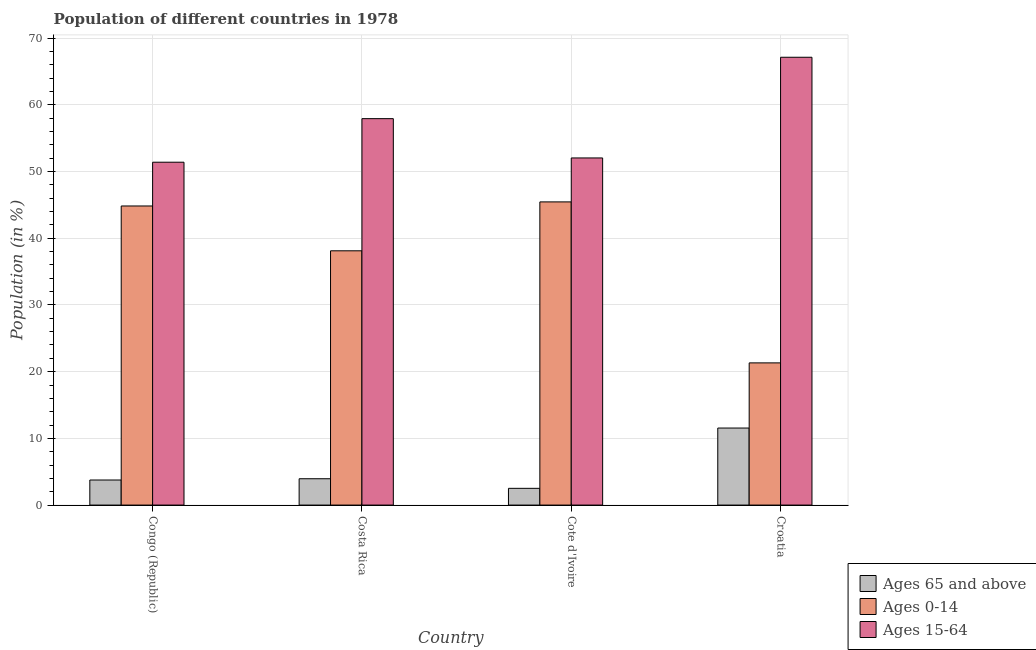Are the number of bars per tick equal to the number of legend labels?
Your response must be concise. Yes. How many bars are there on the 1st tick from the right?
Ensure brevity in your answer.  3. What is the label of the 4th group of bars from the left?
Give a very brief answer. Croatia. In how many cases, is the number of bars for a given country not equal to the number of legend labels?
Your response must be concise. 0. What is the percentage of population within the age-group of 65 and above in Croatia?
Provide a short and direct response. 11.55. Across all countries, what is the maximum percentage of population within the age-group 0-14?
Offer a very short reply. 45.45. Across all countries, what is the minimum percentage of population within the age-group 15-64?
Your response must be concise. 51.4. In which country was the percentage of population within the age-group 0-14 maximum?
Your answer should be compact. Cote d'Ivoire. In which country was the percentage of population within the age-group 15-64 minimum?
Provide a short and direct response. Congo (Republic). What is the total percentage of population within the age-group 0-14 in the graph?
Make the answer very short. 149.73. What is the difference between the percentage of population within the age-group of 65 and above in Costa Rica and that in Croatia?
Provide a short and direct response. -7.6. What is the difference between the percentage of population within the age-group of 65 and above in Croatia and the percentage of population within the age-group 15-64 in Cote d'Ivoire?
Offer a terse response. -40.49. What is the average percentage of population within the age-group of 65 and above per country?
Keep it short and to the point. 5.44. What is the difference between the percentage of population within the age-group of 65 and above and percentage of population within the age-group 0-14 in Costa Rica?
Offer a terse response. -34.17. In how many countries, is the percentage of population within the age-group of 65 and above greater than 22 %?
Your answer should be compact. 0. What is the ratio of the percentage of population within the age-group 0-14 in Congo (Republic) to that in Cote d'Ivoire?
Give a very brief answer. 0.99. Is the percentage of population within the age-group 15-64 in Cote d'Ivoire less than that in Croatia?
Make the answer very short. Yes. What is the difference between the highest and the second highest percentage of population within the age-group 0-14?
Provide a succinct answer. 0.61. What is the difference between the highest and the lowest percentage of population within the age-group 0-14?
Your response must be concise. 24.13. What does the 1st bar from the left in Congo (Republic) represents?
Give a very brief answer. Ages 65 and above. What does the 3rd bar from the right in Cote d'Ivoire represents?
Give a very brief answer. Ages 65 and above. Is it the case that in every country, the sum of the percentage of population within the age-group of 65 and above and percentage of population within the age-group 0-14 is greater than the percentage of population within the age-group 15-64?
Provide a short and direct response. No. Are all the bars in the graph horizontal?
Offer a very short reply. No. How many countries are there in the graph?
Offer a very short reply. 4. Does the graph contain any zero values?
Keep it short and to the point. No. Where does the legend appear in the graph?
Your answer should be compact. Bottom right. How many legend labels are there?
Make the answer very short. 3. What is the title of the graph?
Your response must be concise. Population of different countries in 1978. What is the label or title of the X-axis?
Give a very brief answer. Country. What is the Population (in %) in Ages 65 and above in Congo (Republic)?
Offer a terse response. 3.76. What is the Population (in %) of Ages 0-14 in Congo (Republic)?
Your response must be concise. 44.84. What is the Population (in %) in Ages 15-64 in Congo (Republic)?
Your response must be concise. 51.4. What is the Population (in %) of Ages 65 and above in Costa Rica?
Your answer should be very brief. 3.95. What is the Population (in %) in Ages 0-14 in Costa Rica?
Your response must be concise. 38.12. What is the Population (in %) in Ages 15-64 in Costa Rica?
Your answer should be compact. 57.93. What is the Population (in %) in Ages 65 and above in Cote d'Ivoire?
Keep it short and to the point. 2.51. What is the Population (in %) in Ages 0-14 in Cote d'Ivoire?
Make the answer very short. 45.45. What is the Population (in %) in Ages 15-64 in Cote d'Ivoire?
Your answer should be compact. 52.04. What is the Population (in %) of Ages 65 and above in Croatia?
Make the answer very short. 11.55. What is the Population (in %) of Ages 0-14 in Croatia?
Provide a short and direct response. 21.32. What is the Population (in %) in Ages 15-64 in Croatia?
Give a very brief answer. 67.14. Across all countries, what is the maximum Population (in %) of Ages 65 and above?
Give a very brief answer. 11.55. Across all countries, what is the maximum Population (in %) of Ages 0-14?
Provide a succinct answer. 45.45. Across all countries, what is the maximum Population (in %) in Ages 15-64?
Provide a succinct answer. 67.14. Across all countries, what is the minimum Population (in %) of Ages 65 and above?
Offer a terse response. 2.51. Across all countries, what is the minimum Population (in %) of Ages 0-14?
Your response must be concise. 21.32. Across all countries, what is the minimum Population (in %) of Ages 15-64?
Give a very brief answer. 51.4. What is the total Population (in %) in Ages 65 and above in the graph?
Offer a very short reply. 21.76. What is the total Population (in %) of Ages 0-14 in the graph?
Your answer should be compact. 149.73. What is the total Population (in %) of Ages 15-64 in the graph?
Offer a very short reply. 228.51. What is the difference between the Population (in %) of Ages 65 and above in Congo (Republic) and that in Costa Rica?
Your answer should be compact. -0.19. What is the difference between the Population (in %) in Ages 0-14 in Congo (Republic) and that in Costa Rica?
Offer a terse response. 6.72. What is the difference between the Population (in %) of Ages 15-64 in Congo (Republic) and that in Costa Rica?
Give a very brief answer. -6.53. What is the difference between the Population (in %) in Ages 65 and above in Congo (Republic) and that in Cote d'Ivoire?
Ensure brevity in your answer.  1.25. What is the difference between the Population (in %) in Ages 0-14 in Congo (Republic) and that in Cote d'Ivoire?
Offer a terse response. -0.61. What is the difference between the Population (in %) in Ages 15-64 in Congo (Republic) and that in Cote d'Ivoire?
Ensure brevity in your answer.  -0.64. What is the difference between the Population (in %) in Ages 65 and above in Congo (Republic) and that in Croatia?
Give a very brief answer. -7.79. What is the difference between the Population (in %) in Ages 0-14 in Congo (Republic) and that in Croatia?
Keep it short and to the point. 23.52. What is the difference between the Population (in %) of Ages 15-64 in Congo (Republic) and that in Croatia?
Give a very brief answer. -15.73. What is the difference between the Population (in %) in Ages 65 and above in Costa Rica and that in Cote d'Ivoire?
Give a very brief answer. 1.44. What is the difference between the Population (in %) in Ages 0-14 in Costa Rica and that in Cote d'Ivoire?
Ensure brevity in your answer.  -7.33. What is the difference between the Population (in %) of Ages 15-64 in Costa Rica and that in Cote d'Ivoire?
Keep it short and to the point. 5.89. What is the difference between the Population (in %) in Ages 65 and above in Costa Rica and that in Croatia?
Give a very brief answer. -7.6. What is the difference between the Population (in %) of Ages 0-14 in Costa Rica and that in Croatia?
Ensure brevity in your answer.  16.8. What is the difference between the Population (in %) in Ages 15-64 in Costa Rica and that in Croatia?
Give a very brief answer. -9.2. What is the difference between the Population (in %) in Ages 65 and above in Cote d'Ivoire and that in Croatia?
Give a very brief answer. -9.04. What is the difference between the Population (in %) of Ages 0-14 in Cote d'Ivoire and that in Croatia?
Offer a terse response. 24.13. What is the difference between the Population (in %) in Ages 15-64 in Cote d'Ivoire and that in Croatia?
Give a very brief answer. -15.09. What is the difference between the Population (in %) in Ages 65 and above in Congo (Republic) and the Population (in %) in Ages 0-14 in Costa Rica?
Your response must be concise. -34.36. What is the difference between the Population (in %) of Ages 65 and above in Congo (Republic) and the Population (in %) of Ages 15-64 in Costa Rica?
Make the answer very short. -54.18. What is the difference between the Population (in %) in Ages 0-14 in Congo (Republic) and the Population (in %) in Ages 15-64 in Costa Rica?
Your answer should be very brief. -13.09. What is the difference between the Population (in %) in Ages 65 and above in Congo (Republic) and the Population (in %) in Ages 0-14 in Cote d'Ivoire?
Your answer should be compact. -41.69. What is the difference between the Population (in %) of Ages 65 and above in Congo (Republic) and the Population (in %) of Ages 15-64 in Cote d'Ivoire?
Your response must be concise. -48.28. What is the difference between the Population (in %) in Ages 0-14 in Congo (Republic) and the Population (in %) in Ages 15-64 in Cote d'Ivoire?
Your answer should be compact. -7.2. What is the difference between the Population (in %) in Ages 65 and above in Congo (Republic) and the Population (in %) in Ages 0-14 in Croatia?
Offer a terse response. -17.56. What is the difference between the Population (in %) in Ages 65 and above in Congo (Republic) and the Population (in %) in Ages 15-64 in Croatia?
Ensure brevity in your answer.  -63.38. What is the difference between the Population (in %) of Ages 0-14 in Congo (Republic) and the Population (in %) of Ages 15-64 in Croatia?
Ensure brevity in your answer.  -22.29. What is the difference between the Population (in %) in Ages 65 and above in Costa Rica and the Population (in %) in Ages 0-14 in Cote d'Ivoire?
Your response must be concise. -41.5. What is the difference between the Population (in %) of Ages 65 and above in Costa Rica and the Population (in %) of Ages 15-64 in Cote d'Ivoire?
Offer a terse response. -48.09. What is the difference between the Population (in %) of Ages 0-14 in Costa Rica and the Population (in %) of Ages 15-64 in Cote d'Ivoire?
Keep it short and to the point. -13.92. What is the difference between the Population (in %) in Ages 65 and above in Costa Rica and the Population (in %) in Ages 0-14 in Croatia?
Offer a very short reply. -17.37. What is the difference between the Population (in %) of Ages 65 and above in Costa Rica and the Population (in %) of Ages 15-64 in Croatia?
Provide a short and direct response. -63.19. What is the difference between the Population (in %) in Ages 0-14 in Costa Rica and the Population (in %) in Ages 15-64 in Croatia?
Your answer should be very brief. -29.02. What is the difference between the Population (in %) in Ages 65 and above in Cote d'Ivoire and the Population (in %) in Ages 0-14 in Croatia?
Keep it short and to the point. -18.81. What is the difference between the Population (in %) in Ages 65 and above in Cote d'Ivoire and the Population (in %) in Ages 15-64 in Croatia?
Provide a succinct answer. -64.63. What is the difference between the Population (in %) in Ages 0-14 in Cote d'Ivoire and the Population (in %) in Ages 15-64 in Croatia?
Your answer should be very brief. -21.68. What is the average Population (in %) in Ages 65 and above per country?
Provide a succinct answer. 5.44. What is the average Population (in %) of Ages 0-14 per country?
Your answer should be very brief. 37.43. What is the average Population (in %) of Ages 15-64 per country?
Give a very brief answer. 57.13. What is the difference between the Population (in %) in Ages 65 and above and Population (in %) in Ages 0-14 in Congo (Republic)?
Provide a succinct answer. -41.08. What is the difference between the Population (in %) of Ages 65 and above and Population (in %) of Ages 15-64 in Congo (Republic)?
Provide a succinct answer. -47.65. What is the difference between the Population (in %) in Ages 0-14 and Population (in %) in Ages 15-64 in Congo (Republic)?
Your answer should be very brief. -6.56. What is the difference between the Population (in %) in Ages 65 and above and Population (in %) in Ages 0-14 in Costa Rica?
Your response must be concise. -34.17. What is the difference between the Population (in %) of Ages 65 and above and Population (in %) of Ages 15-64 in Costa Rica?
Your answer should be very brief. -53.98. What is the difference between the Population (in %) in Ages 0-14 and Population (in %) in Ages 15-64 in Costa Rica?
Your answer should be very brief. -19.81. What is the difference between the Population (in %) in Ages 65 and above and Population (in %) in Ages 0-14 in Cote d'Ivoire?
Provide a short and direct response. -42.94. What is the difference between the Population (in %) in Ages 65 and above and Population (in %) in Ages 15-64 in Cote d'Ivoire?
Your answer should be compact. -49.53. What is the difference between the Population (in %) in Ages 0-14 and Population (in %) in Ages 15-64 in Cote d'Ivoire?
Keep it short and to the point. -6.59. What is the difference between the Population (in %) of Ages 65 and above and Population (in %) of Ages 0-14 in Croatia?
Offer a terse response. -9.77. What is the difference between the Population (in %) in Ages 65 and above and Population (in %) in Ages 15-64 in Croatia?
Ensure brevity in your answer.  -55.59. What is the difference between the Population (in %) of Ages 0-14 and Population (in %) of Ages 15-64 in Croatia?
Give a very brief answer. -45.82. What is the ratio of the Population (in %) in Ages 65 and above in Congo (Republic) to that in Costa Rica?
Your answer should be compact. 0.95. What is the ratio of the Population (in %) in Ages 0-14 in Congo (Republic) to that in Costa Rica?
Keep it short and to the point. 1.18. What is the ratio of the Population (in %) of Ages 15-64 in Congo (Republic) to that in Costa Rica?
Offer a terse response. 0.89. What is the ratio of the Population (in %) in Ages 65 and above in Congo (Republic) to that in Cote d'Ivoire?
Provide a short and direct response. 1.5. What is the ratio of the Population (in %) of Ages 0-14 in Congo (Republic) to that in Cote d'Ivoire?
Give a very brief answer. 0.99. What is the ratio of the Population (in %) of Ages 65 and above in Congo (Republic) to that in Croatia?
Offer a very short reply. 0.33. What is the ratio of the Population (in %) of Ages 0-14 in Congo (Republic) to that in Croatia?
Provide a short and direct response. 2.1. What is the ratio of the Population (in %) in Ages 15-64 in Congo (Republic) to that in Croatia?
Offer a terse response. 0.77. What is the ratio of the Population (in %) of Ages 65 and above in Costa Rica to that in Cote d'Ivoire?
Provide a short and direct response. 1.57. What is the ratio of the Population (in %) in Ages 0-14 in Costa Rica to that in Cote d'Ivoire?
Offer a very short reply. 0.84. What is the ratio of the Population (in %) of Ages 15-64 in Costa Rica to that in Cote d'Ivoire?
Keep it short and to the point. 1.11. What is the ratio of the Population (in %) of Ages 65 and above in Costa Rica to that in Croatia?
Make the answer very short. 0.34. What is the ratio of the Population (in %) of Ages 0-14 in Costa Rica to that in Croatia?
Your response must be concise. 1.79. What is the ratio of the Population (in %) of Ages 15-64 in Costa Rica to that in Croatia?
Offer a very short reply. 0.86. What is the ratio of the Population (in %) of Ages 65 and above in Cote d'Ivoire to that in Croatia?
Provide a succinct answer. 0.22. What is the ratio of the Population (in %) of Ages 0-14 in Cote d'Ivoire to that in Croatia?
Make the answer very short. 2.13. What is the ratio of the Population (in %) of Ages 15-64 in Cote d'Ivoire to that in Croatia?
Provide a short and direct response. 0.78. What is the difference between the highest and the second highest Population (in %) in Ages 65 and above?
Your answer should be compact. 7.6. What is the difference between the highest and the second highest Population (in %) in Ages 0-14?
Offer a very short reply. 0.61. What is the difference between the highest and the second highest Population (in %) of Ages 15-64?
Your response must be concise. 9.2. What is the difference between the highest and the lowest Population (in %) of Ages 65 and above?
Provide a short and direct response. 9.04. What is the difference between the highest and the lowest Population (in %) of Ages 0-14?
Make the answer very short. 24.13. What is the difference between the highest and the lowest Population (in %) in Ages 15-64?
Give a very brief answer. 15.73. 